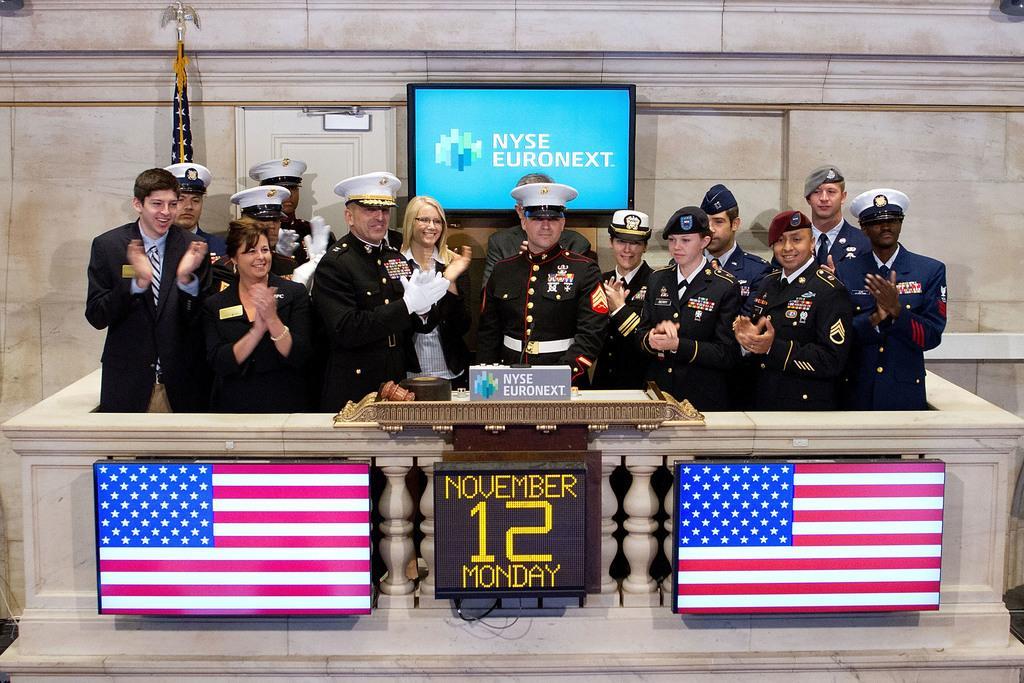Describe this image in one or two sentences. In this picture I can see few people standing they wore caps on there heads and i can see couple of television displaying flag on it and I can see a digital display of date and I can see a television on the back to the wall and I can see text displaying on it and the flag on the side and I can see a wall on the back and a box in the front on the table. 